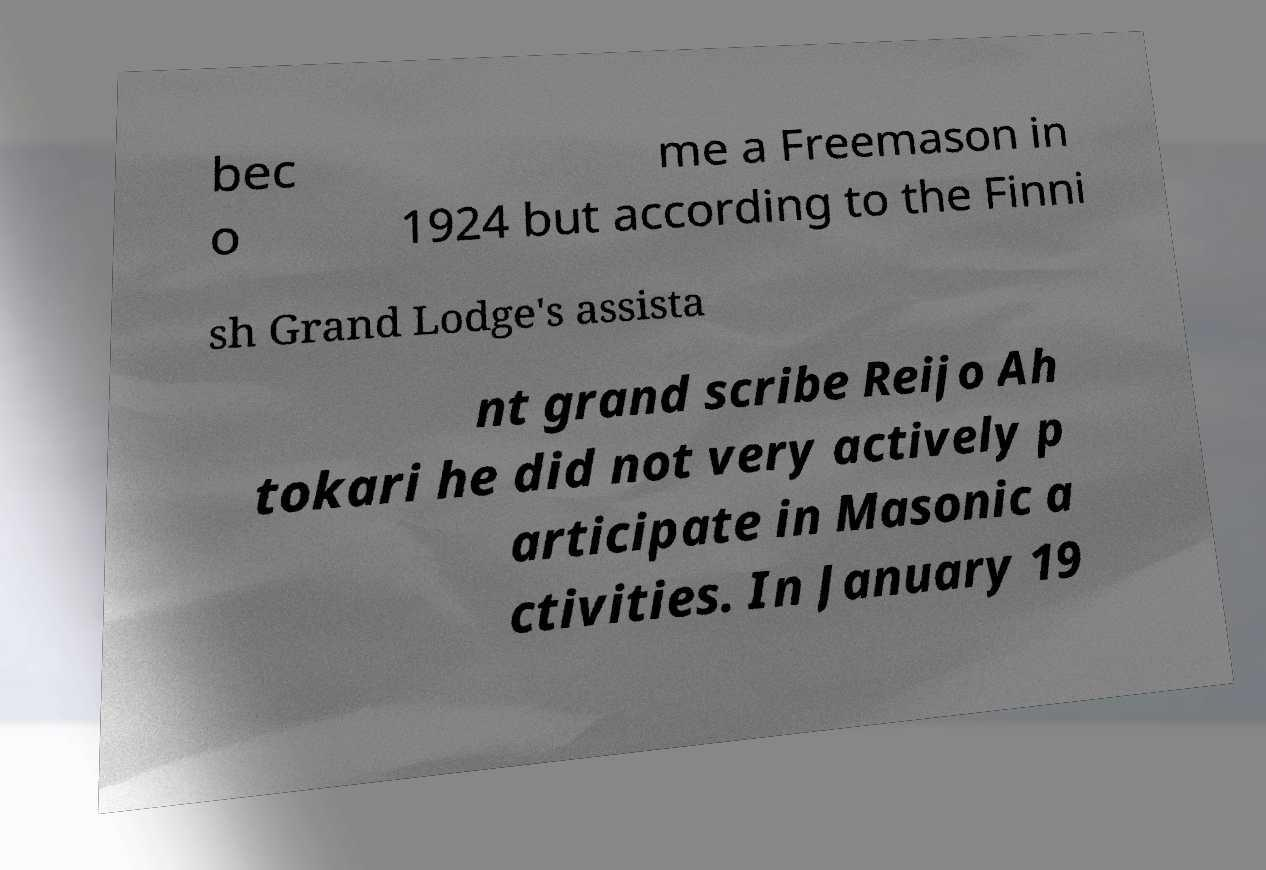Can you read and provide the text displayed in the image?This photo seems to have some interesting text. Can you extract and type it out for me? bec o me a Freemason in 1924 but according to the Finni sh Grand Lodge's assista nt grand scribe Reijo Ah tokari he did not very actively p articipate in Masonic a ctivities. In January 19 